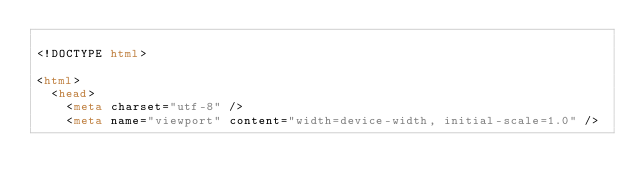<code> <loc_0><loc_0><loc_500><loc_500><_HTML_>
<!DOCTYPE html>

<html>
  <head>
    <meta charset="utf-8" />
    <meta name="viewport" content="width=device-width, initial-scale=1.0" /></code> 